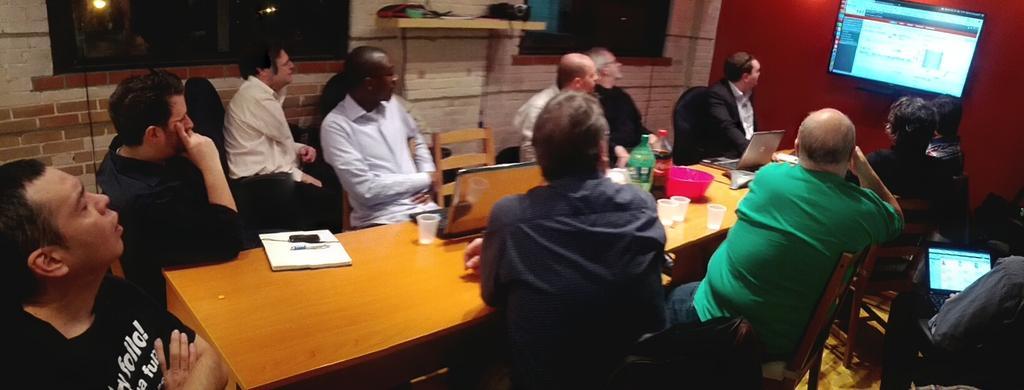Describe this image in one or two sentences. This is a picture taken in a room, there are a group of people sitting on chairs some people are holding laptop. In front of these people there is a table on the table there are book, cup, laptops, bowl and bottle. Behind the people there is a glass window, wall. In front of the people there is a wall on the wall there is a television screen. 